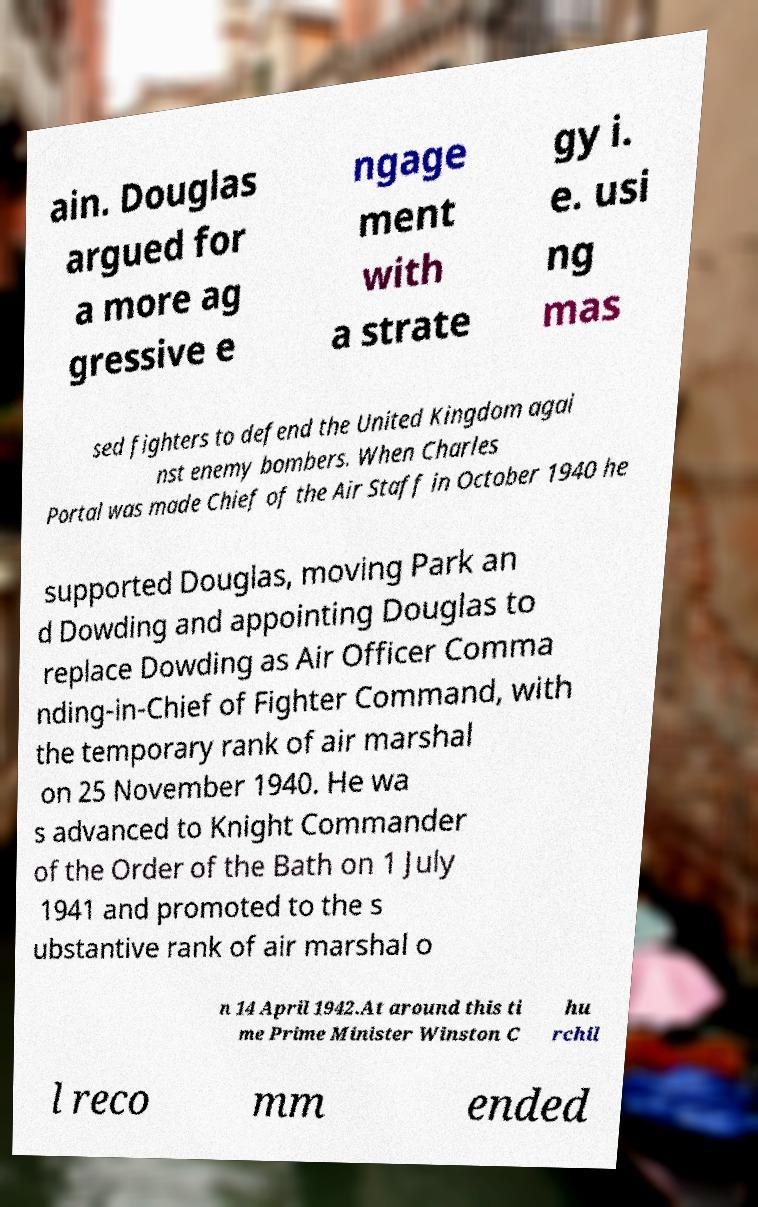Can you accurately transcribe the text from the provided image for me? ain. Douglas argued for a more ag gressive e ngage ment with a strate gy i. e. usi ng mas sed fighters to defend the United Kingdom agai nst enemy bombers. When Charles Portal was made Chief of the Air Staff in October 1940 he supported Douglas, moving Park an d Dowding and appointing Douglas to replace Dowding as Air Officer Comma nding-in-Chief of Fighter Command, with the temporary rank of air marshal on 25 November 1940. He wa s advanced to Knight Commander of the Order of the Bath on 1 July 1941 and promoted to the s ubstantive rank of air marshal o n 14 April 1942.At around this ti me Prime Minister Winston C hu rchil l reco mm ended 